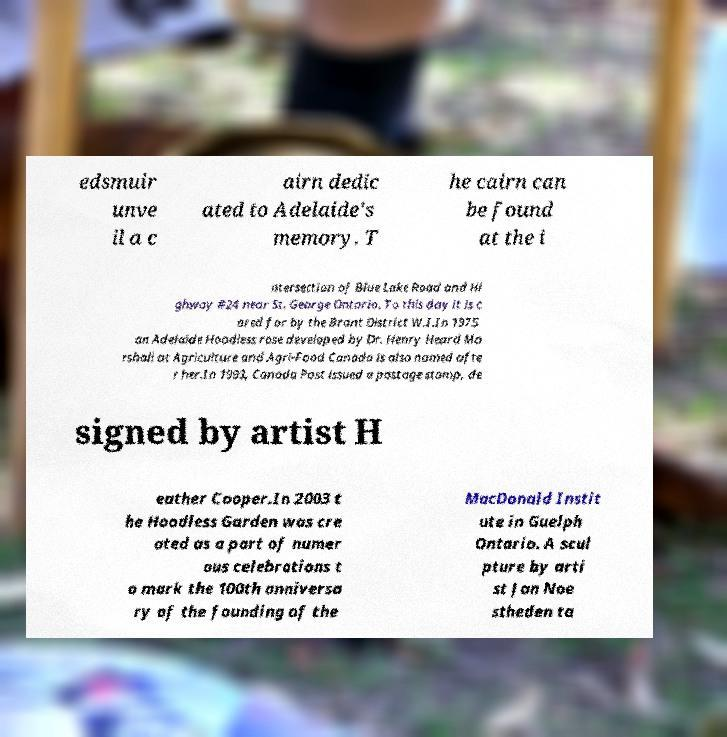Can you read and provide the text displayed in the image?This photo seems to have some interesting text. Can you extract and type it out for me? edsmuir unve il a c airn dedic ated to Adelaide's memory. T he cairn can be found at the i ntersection of Blue Lake Road and Hi ghway #24 near St. George Ontario. To this day it is c ared for by the Brant District W.I.In 1975 an Adelaide Hoodless rose developed by Dr. Henry Heard Ma rshall at Agriculture and Agri-Food Canada is also named afte r her.In 1993, Canada Post issued a postage stamp, de signed by artist H eather Cooper.In 2003 t he Hoodless Garden was cre ated as a part of numer ous celebrations t o mark the 100th anniversa ry of the founding of the MacDonald Instit ute in Guelph Ontario. A scul pture by arti st Jan Noe stheden ta 